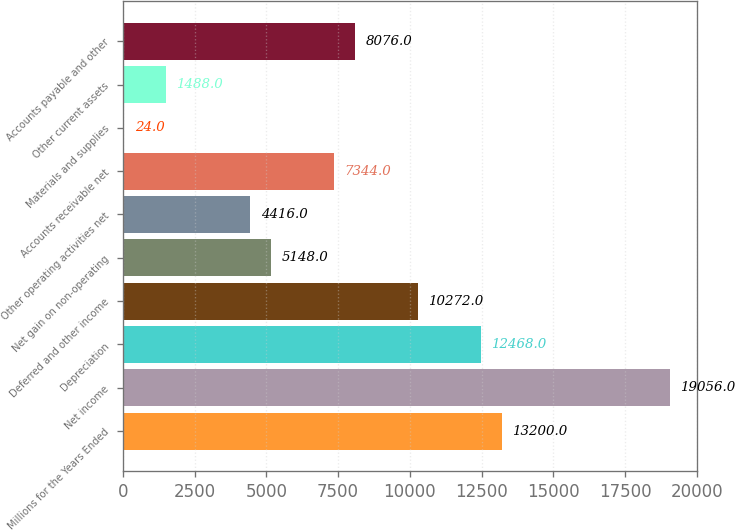Convert chart. <chart><loc_0><loc_0><loc_500><loc_500><bar_chart><fcel>Millions for the Years Ended<fcel>Net income<fcel>Depreciation<fcel>Deferred and other income<fcel>Net gain on non-operating<fcel>Other operating activities net<fcel>Accounts receivable net<fcel>Materials and supplies<fcel>Other current assets<fcel>Accounts payable and other<nl><fcel>13200<fcel>19056<fcel>12468<fcel>10272<fcel>5148<fcel>4416<fcel>7344<fcel>24<fcel>1488<fcel>8076<nl></chart> 